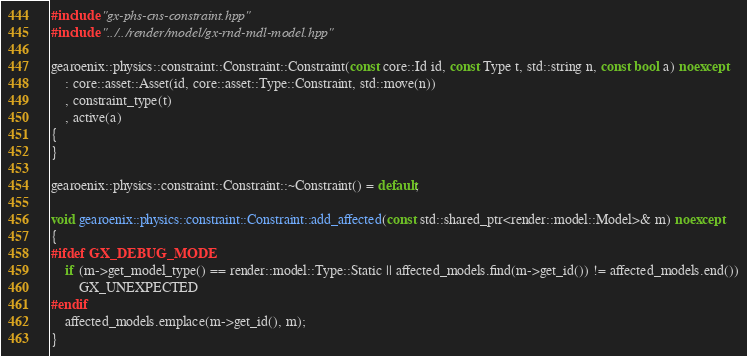<code> <loc_0><loc_0><loc_500><loc_500><_C++_>#include "gx-phs-cns-constraint.hpp"
#include "../../render/model/gx-rnd-mdl-model.hpp"

gearoenix::physics::constraint::Constraint::Constraint(const core::Id id, const Type t, std::string n, const bool a) noexcept
    : core::asset::Asset(id, core::asset::Type::Constraint, std::move(n))
    , constraint_type(t)
    , active(a)
{
}

gearoenix::physics::constraint::Constraint::~Constraint() = default;

void gearoenix::physics::constraint::Constraint::add_affected(const std::shared_ptr<render::model::Model>& m) noexcept
{
#ifdef GX_DEBUG_MODE
    if (m->get_model_type() == render::model::Type::Static || affected_models.find(m->get_id()) != affected_models.end())
        GX_UNEXPECTED
#endif
    affected_models.emplace(m->get_id(), m);
}</code> 